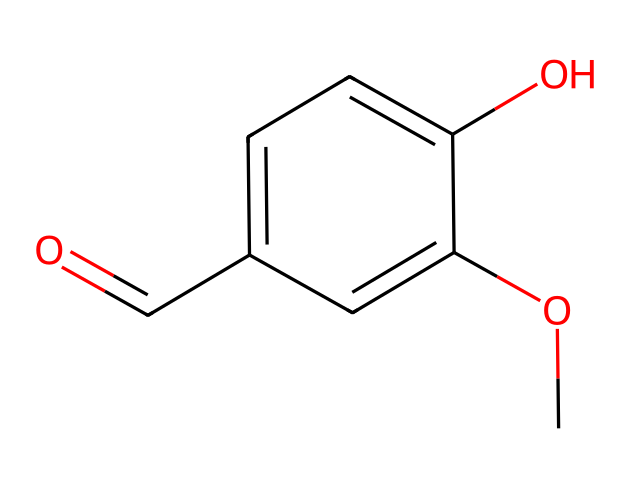What is the molecular formula of vanillin? By analyzing the SMILES representation, we can determine the number of each type of atom present. The formula includes 8 carbons, 8 hydrogens, and 3 oxygens, resulting in C8H8O3.
Answer: C8H8O3 How many hydroxyl (-OH) groups are present in this structure? The chemical structure shows one hydroxyl group directly bonded to the aromatic ring (indicated by "O" followed by "c"), confirming the presence of a single -OH group.
Answer: 1 What functional group is represented by the -O-CH3 in the structure? The -O-CH3 group is a methoxy group (O bonded to a methyl group) and is characteristic of ethers, indicating this molecule contains an ether functional group.
Answer: methoxy Is vanillin classified as a phenol? The presence of a hydroxyl group directly bonded to an aromatic carbon means that vanillin fits the definition of a phenol, which is a compound with this specific arrangement.
Answer: Yes What type of compound is vanillin specifically categorized as? Vanillin is categorized as both an aromatic aldehyde and a phenolic compound due to its functional groups; it contains an aldehyde (C=O) and a phenolic -OH group.
Answer: aromatic aldehyde Which aromatic property does the presence of -OH impart to vanillin? The -OH group enhances the aromatic character of the compound by allowing for hydrogen bonding, which improves solubility in polar solvents and contributes to its flavor.
Answer: solubility What is the total number of rings in vanillin's structure? The structure includes one aromatic ring, which is the only ring present in the molecular architecture of vanillin, making the total count one.
Answer: 1 